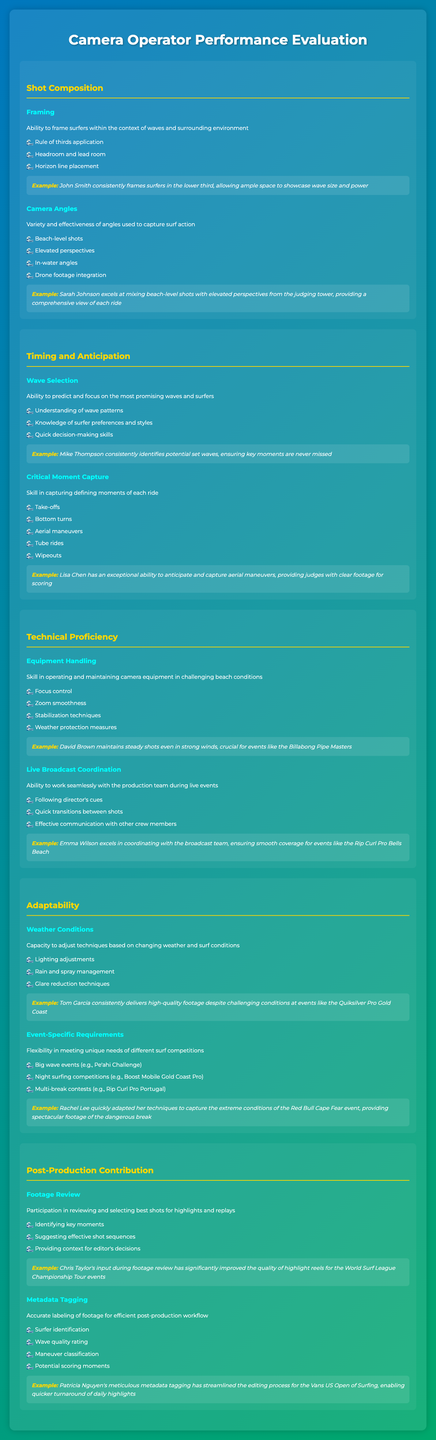What is the description of shot composition? The description outlines the ability of camera operators to effectively frame surfers in relation to waves and the surrounding environment.
Answer: Ability to frame surfers within the context of waves and surrounding environment Who excels at capturing aerial maneuvers? The document provides an example of a camera operator who has a notable skill in anticipating and capturing aerial maneuvers.
Answer: Lisa Chen What types of camera angles are mentioned? This question seeks the list of different camera angles utilized by operators during surf events according to the document.
Answer: Beach-level shots, Elevated perspectives, In-water angles, Drone footage integration How does Tom Garcia adapt to challenging conditions? The document discusses adaptability regarding weather conditions and mentions a specific operator's ability to handle such scenarios.
Answer: Consistently delivers high-quality footage despite challenging conditions What is one key factor in wave selection? The document lists factors that influence a camera operator's ability to select promising waves, looking for one specific factor.
Answer: Understanding of wave patterns In which event did Rachel Lee adapt her techniques? The text references a specific event where adaptability in techniques was crucial for capturing the surf action.
Answer: Red Bull Cape Fear event What does Chris Taylor contribute to post-production? This question focuses on the contributions of a specific operator in the post-production process as described in the document.
Answer: Participation in reviewing and selecting best shots for highlights and replays 